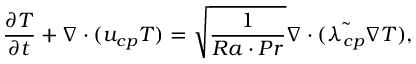Convert formula to latex. <formula><loc_0><loc_0><loc_500><loc_500>\frac { \partial T } { \partial t } + \nabla \cdot ( u _ { c p } T ) = \sqrt { \frac { 1 } { R a \cdot P r } } \nabla \cdot ( { \tilde { \lambda _ { c p } } \nabla T } ) ,</formula> 